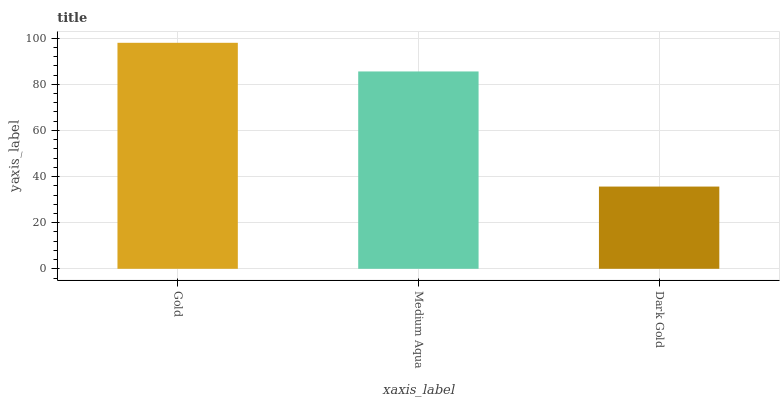Is Dark Gold the minimum?
Answer yes or no. Yes. Is Gold the maximum?
Answer yes or no. Yes. Is Medium Aqua the minimum?
Answer yes or no. No. Is Medium Aqua the maximum?
Answer yes or no. No. Is Gold greater than Medium Aqua?
Answer yes or no. Yes. Is Medium Aqua less than Gold?
Answer yes or no. Yes. Is Medium Aqua greater than Gold?
Answer yes or no. No. Is Gold less than Medium Aqua?
Answer yes or no. No. Is Medium Aqua the high median?
Answer yes or no. Yes. Is Medium Aqua the low median?
Answer yes or no. Yes. Is Gold the high median?
Answer yes or no. No. Is Dark Gold the low median?
Answer yes or no. No. 